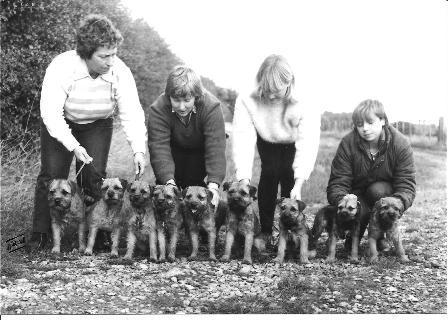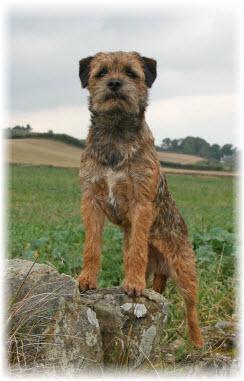The first image is the image on the left, the second image is the image on the right. Assess this claim about the two images: "One image shows a dog standing wearing a harness and facing leftward.". Correct or not? Answer yes or no. No. The first image is the image on the left, the second image is the image on the right. For the images shown, is this caption "A single dog is standing alone in the grass in the image on the left." true? Answer yes or no. No. 